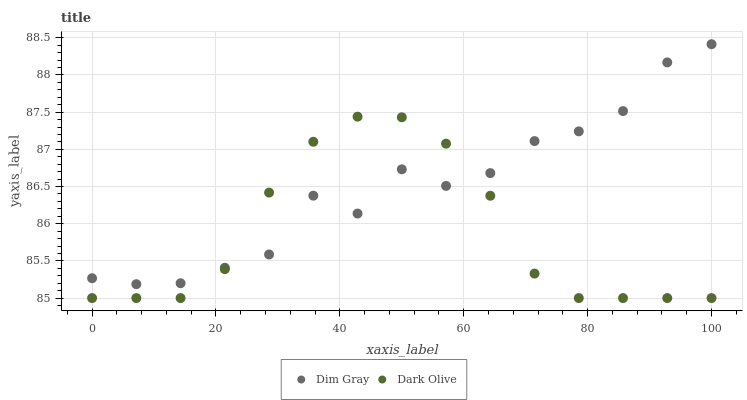Does Dark Olive have the minimum area under the curve?
Answer yes or no. Yes. Does Dim Gray have the maximum area under the curve?
Answer yes or no. Yes. Does Dim Gray have the minimum area under the curve?
Answer yes or no. No. Is Dark Olive the smoothest?
Answer yes or no. Yes. Is Dim Gray the roughest?
Answer yes or no. Yes. Is Dim Gray the smoothest?
Answer yes or no. No. Does Dark Olive have the lowest value?
Answer yes or no. Yes. Does Dim Gray have the lowest value?
Answer yes or no. No. Does Dim Gray have the highest value?
Answer yes or no. Yes. Does Dark Olive intersect Dim Gray?
Answer yes or no. Yes. Is Dark Olive less than Dim Gray?
Answer yes or no. No. Is Dark Olive greater than Dim Gray?
Answer yes or no. No. 